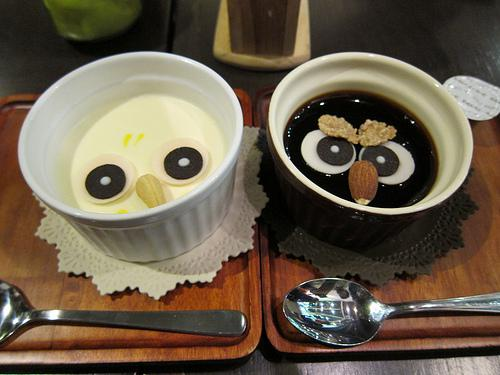Question: where are faces?
Choices:
A. In the coffee.
B. In the mirror.
C. In the window.
D. On the napkins.
Answer with the letter. Answer: A Question: where are trays?
Choices:
A. On the counter.
B. In the sink.
C. On a table.
D. In the trash.
Answer with the letter. Answer: C Question: where are spoons?
Choices:
A. In the sink.
B. On the plate.
C. Wrapped in plastic.
D. On trays.
Answer with the letter. Answer: D Question: what is silver?
Choices:
A. Candlesticks.
B. Knife.
C. Pan.
D. Spoons.
Answer with the letter. Answer: D Question: how many mugs are there?
Choices:
A. Only two.
B. Three.
C. One.
D. Four.
Answer with the letter. Answer: A Question: what is white?
Choices:
A. Plate.
B. Mug on left.
C. Candle.
D. Napkin.
Answer with the letter. Answer: B 